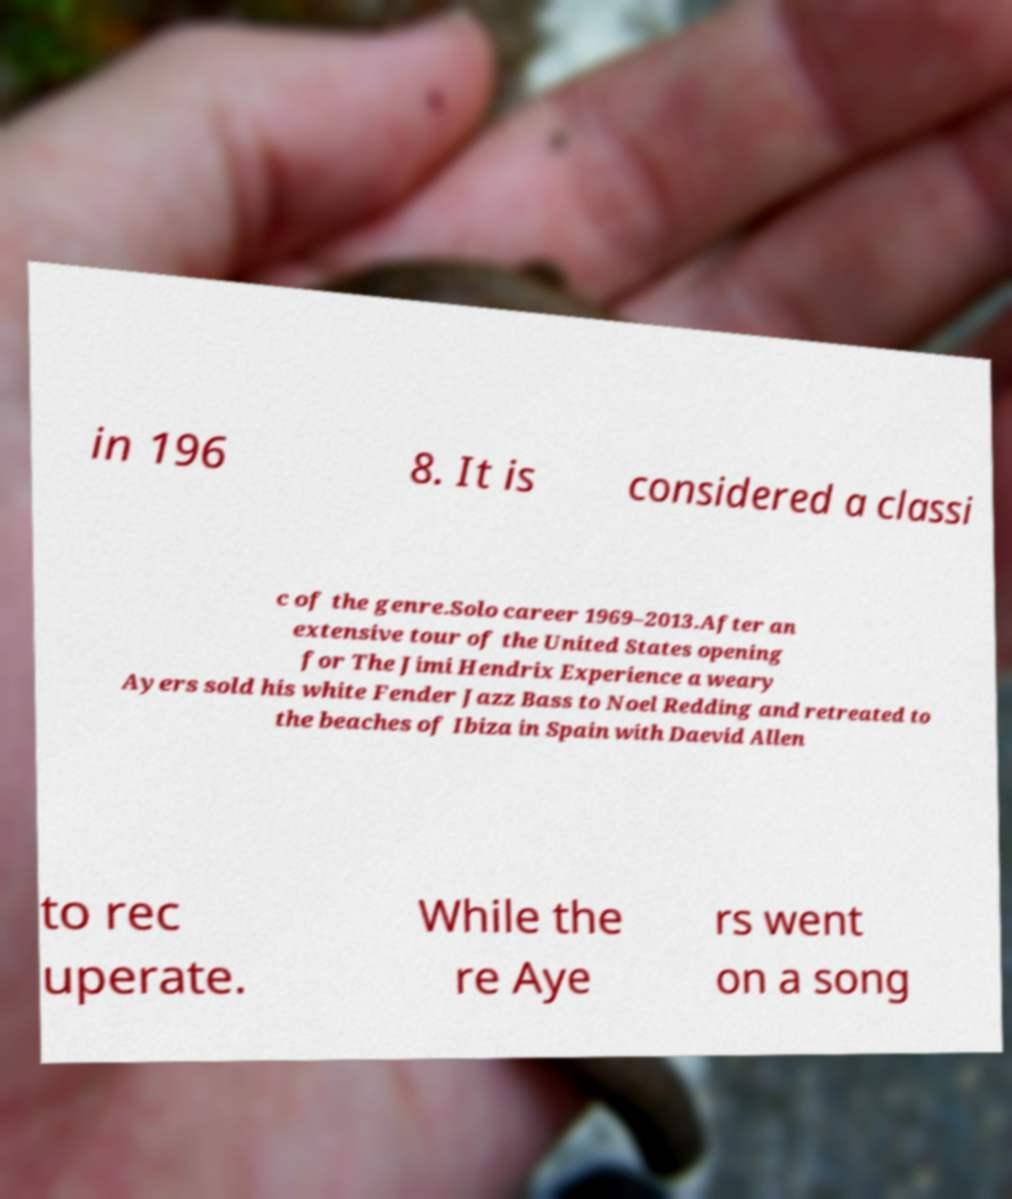Could you assist in decoding the text presented in this image and type it out clearly? in 196 8. It is considered a classi c of the genre.Solo career 1969–2013.After an extensive tour of the United States opening for The Jimi Hendrix Experience a weary Ayers sold his white Fender Jazz Bass to Noel Redding and retreated to the beaches of Ibiza in Spain with Daevid Allen to rec uperate. While the re Aye rs went on a song 